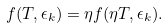Convert formula to latex. <formula><loc_0><loc_0><loc_500><loc_500>f ( T , \epsilon _ { k } ) = \eta f ( \eta T , \epsilon _ { k } ) .</formula> 